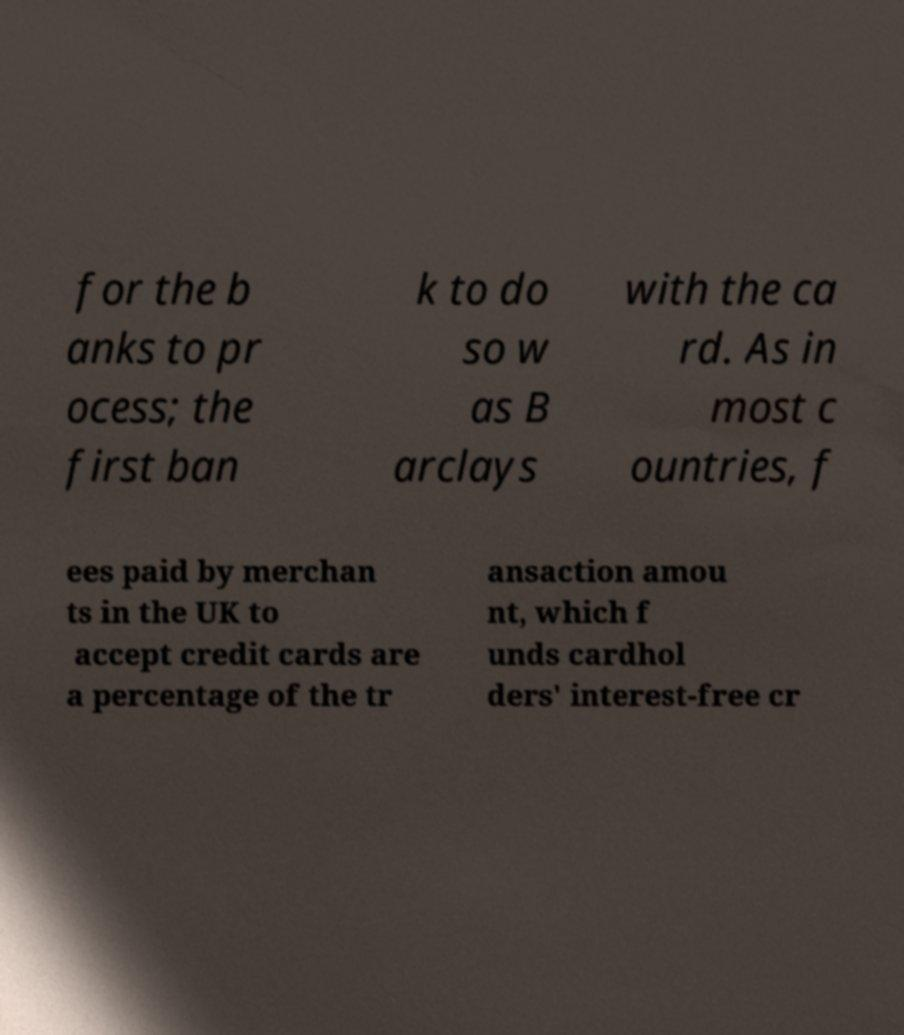Please identify and transcribe the text found in this image. for the b anks to pr ocess; the first ban k to do so w as B arclays with the ca rd. As in most c ountries, f ees paid by merchan ts in the UK to accept credit cards are a percentage of the tr ansaction amou nt, which f unds cardhol ders' interest-free cr 